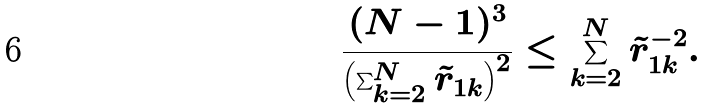<formula> <loc_0><loc_0><loc_500><loc_500>\frac { ( N - 1 ) ^ { 3 } } { \left ( \sum _ { k = 2 } ^ { N } \tilde { r } _ { 1 k } \right ) ^ { 2 } } \leq \sum _ { k = 2 } ^ { N } \tilde { r } _ { 1 k } ^ { - 2 } .</formula> 